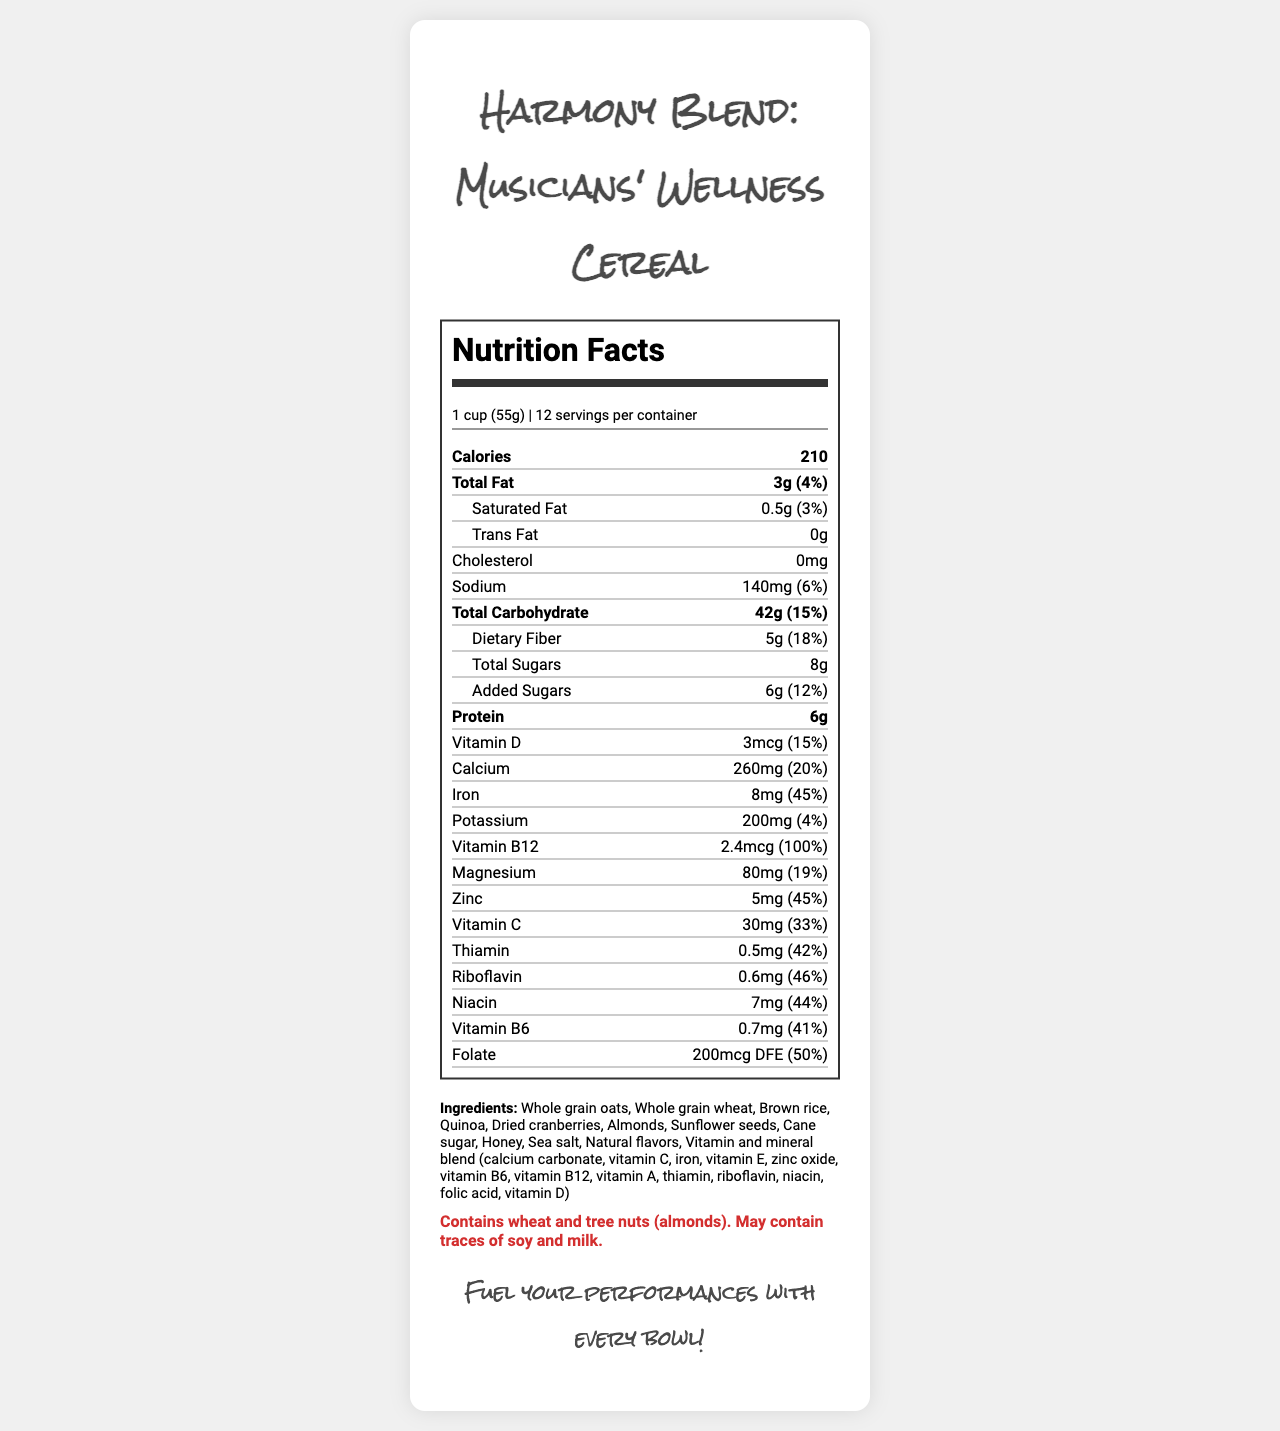what is the serving size? The serving size is stated at the top of the nutrition facts section as "1 cup (55g)".
Answer: 1 cup (55g) how many calories are in one serving? The document lists calories as "210" below the serving information.
Answer: 210 how much protein does one serving contain? The document shows "Protein 6g" towards the middle of the nutrition facts.
Answer: 6g what percentage of daily value is provided by iron? The document lists iron content as "8mg" and "45%" of daily value.
Answer: 45% how many servings are there per container? The servings per container are stated as "12" at the top of the nutrition facts section.
Answer: 12 How much total fat is in one serving? A. 1g B. 2g C. 3g D. 5g The document lists "Total Fat" as "3g".
Answer: C. 3g What is the percentage of daily value for Vitamin C in one serving? i. 15% ii. 25% iii. 33% iv. 50% The document lists "Vitamin C" as "30mg (33%)".
Answer: iii. 33% Is there any cholesterol in the product? The document lists cholesterol as "0mg".
Answer: No Summarize the main nutritional components of this cereal The summary combines the major components such as calories, fats, protein, fiber, and significant vitamins and minerals listed in the nutrition facts.
Answer: The "Harmony Blend: Musicians' Wellness Cereal" provides a balanced nutritional profile with each serving containing 210 calories, 3g of total fat, 6g of protein, high dietary fiber at 5g, and an array of fortified vitamins and minerals like 45% daily value of iron and 100% daily value of Vitamin B12. What is unique about the vitamin B12 content in this cereal? The document lists "Vitamin B12" content as providing "100% daily value," which is notable as no other vitamin in this cereal provides a full 100% daily value.
Answer: 100% daily value Does the document indicate whether this product contains gluten? The document provides the allergen information, stating it contains wheat and tree nuts, but it does not specify whether the product is gluten-free.
Answer: Not enough information 